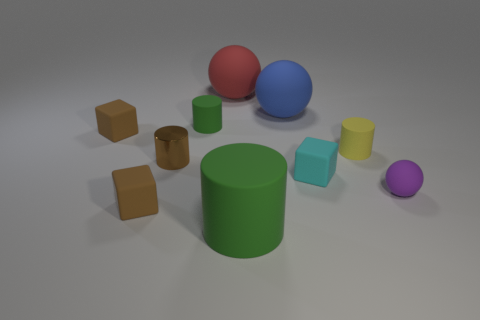Is the tiny green cylinder made of the same material as the small brown thing in front of the small brown cylinder?
Provide a succinct answer. Yes. There is a brown object that is the same shape as the tiny green matte object; what size is it?
Make the answer very short. Small. Are there the same number of brown matte blocks in front of the purple matte thing and small matte cubes behind the red rubber thing?
Provide a succinct answer. No. What number of other objects are the same material as the large green object?
Give a very brief answer. 8. Are there the same number of cubes behind the blue rubber ball and small purple shiny objects?
Keep it short and to the point. Yes. Does the cyan rubber block have the same size as the brown object behind the tiny yellow cylinder?
Your answer should be compact. Yes. There is a green rubber thing that is in front of the tiny brown cylinder; what is its shape?
Ensure brevity in your answer.  Cylinder. Are there any other things that are the same shape as the blue object?
Ensure brevity in your answer.  Yes. Is there a brown metal cylinder?
Offer a very short reply. Yes. There is a matte block behind the tiny yellow matte cylinder; is its size the same as the green cylinder behind the metallic cylinder?
Your answer should be very brief. Yes. 